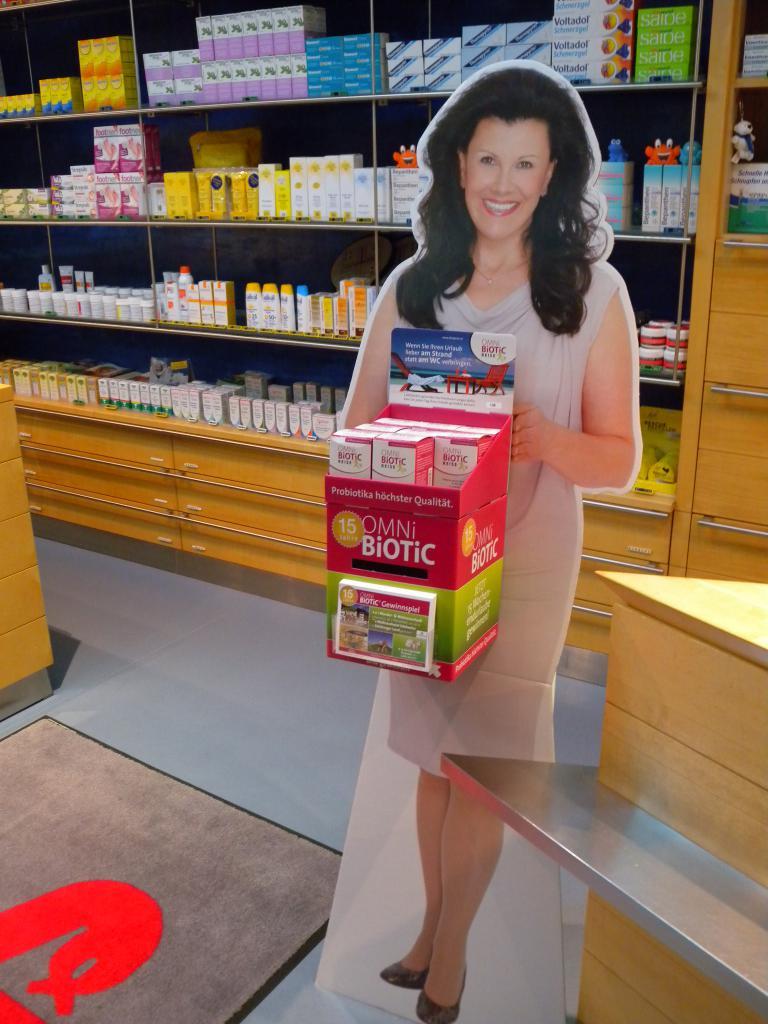What is the product on the stand?
Your answer should be compact. Omni biotic. Is that a real person?
Your answer should be very brief. Answering does not require reading text in the image. 